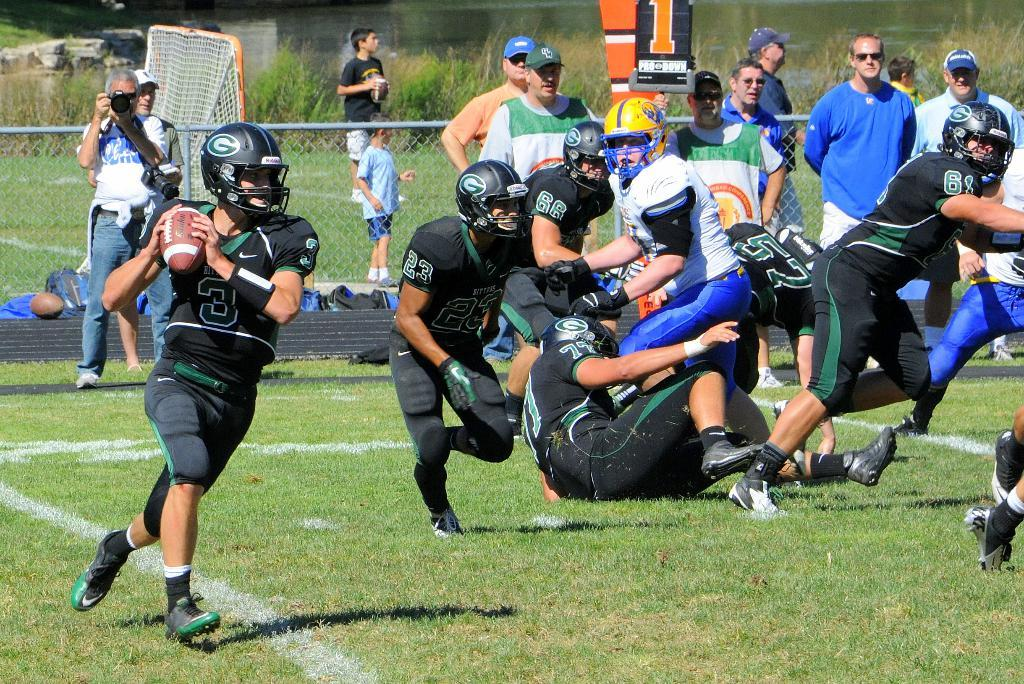What are the players on the ground in the image doing? The players on the ground in the image are likely playing a sport, as there is a net in the background. What can be seen in the background of the image? In the background of the image, there is fencing, grass, a net, and persons. What type of surface are the players on? The players are on a grassy surface, as indicated by the presence of grass in the background. What type of tooth is visible in the image? There is no tooth visible in the image; it features players on a grassy surface with a net in the background. 